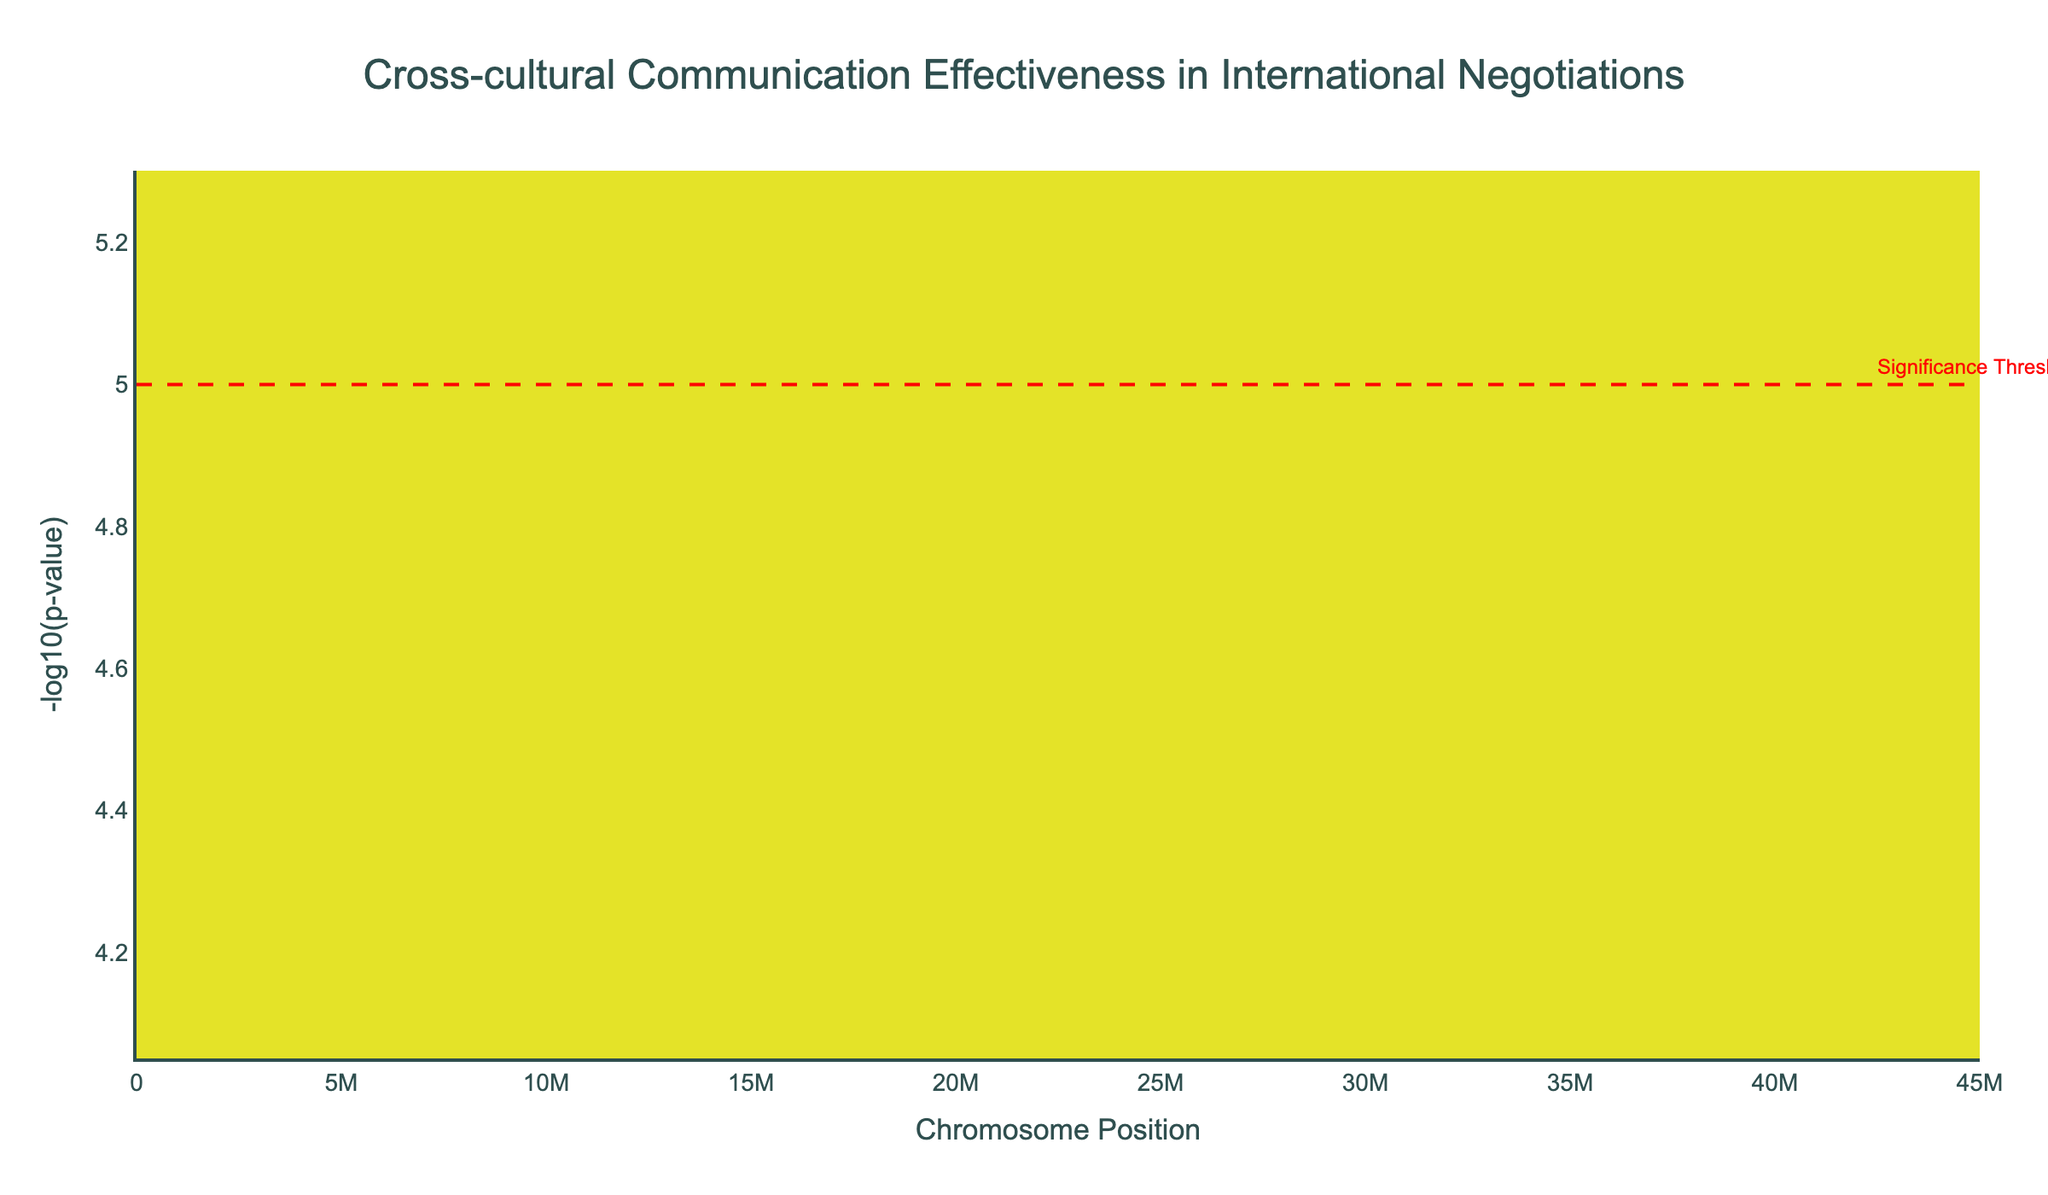What's the title of the plot? The title of the plot is placed at the top and gives an overview of what the figure represents.
Answer: Cross-cultural Communication Effectiveness in International Negotiations What is represented on the y-axis? The y-axis represents the -log10 of the p-values, which is a common way to visualize statistical significance in Manhattan plots.
Answer: -log10(p-value) Which cultural backgrounds have data points that exceed the significance threshold? To determine this, observe the points above the red dashed line, which represents the threshold of -log10(p-value) = 5. Check which cultural backgrounds correspond to these points through their labels.
Answer: South Asian, Southeast Asian, and Russian Which chromosome has the highest concentration of significant data points? Count the number of data points on each chromosome and compare to see which chromosome has the highest number of -log10(p-value) values that exceed the significance threshold (above the red line).
Answer: Chromosome 2 What does the red dashed line indicate? The red dashed line represents the significance threshold of statistical tests, which in this case is set at -log10(p-value) = 5.
Answer: Significance Threshold Which cultural background has the highest -log10(p-value) score? Check the y-axis positions of the data points to see which point is highest, and note the corresponding cultural background through the hover information displayed.
Answer: South Asian How many cultural backgrounds are represented in the plot? Each data point's text value corresponds to a different cultural background. Count the unique labels to determine the number of different cultural backgrounds present.
Answer: 20 What is the value of the significance threshold? The red dashed line’s y-axis position indicates the significance threshold.
Answer: 5 Which chromosome contains the lowest positioned significant data point? Identify the chromosome with the data point having the highest p-value (lowest -log10(p-value) value) in the figure.
Answer: Chromosome 1 